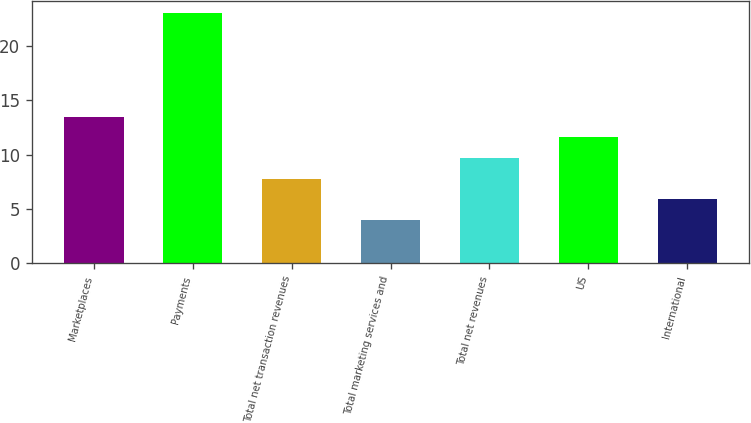Convert chart to OTSL. <chart><loc_0><loc_0><loc_500><loc_500><bar_chart><fcel>Marketplaces<fcel>Payments<fcel>Total net transaction revenues<fcel>Total marketing services and<fcel>Total net revenues<fcel>US<fcel>International<nl><fcel>13.5<fcel>23<fcel>7.8<fcel>4<fcel>9.7<fcel>11.6<fcel>5.9<nl></chart> 